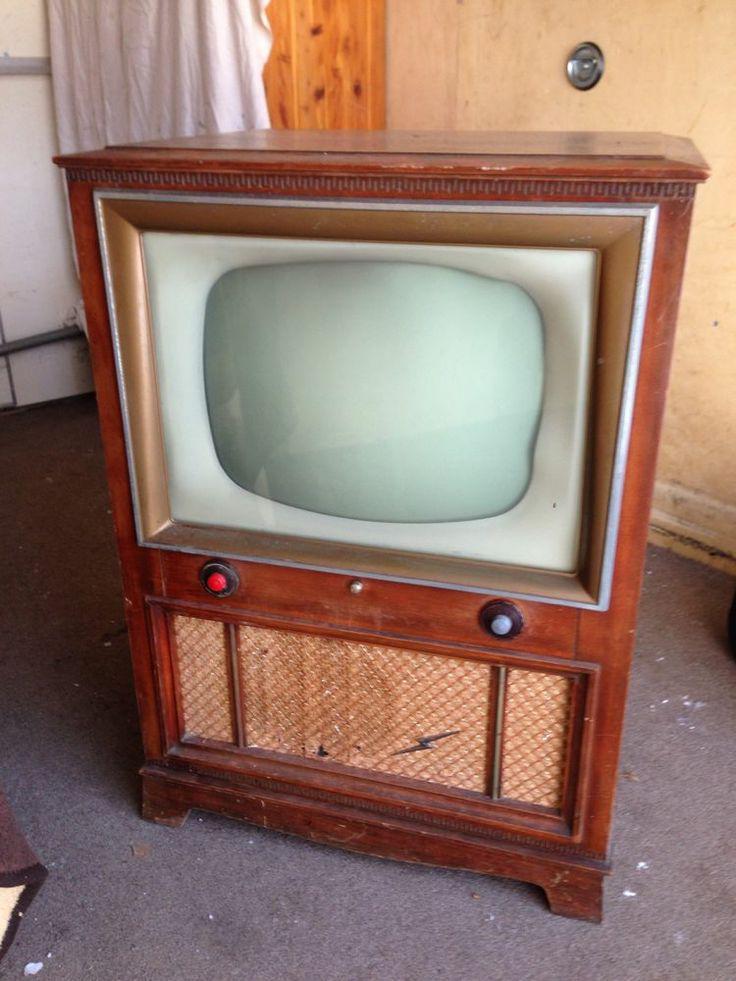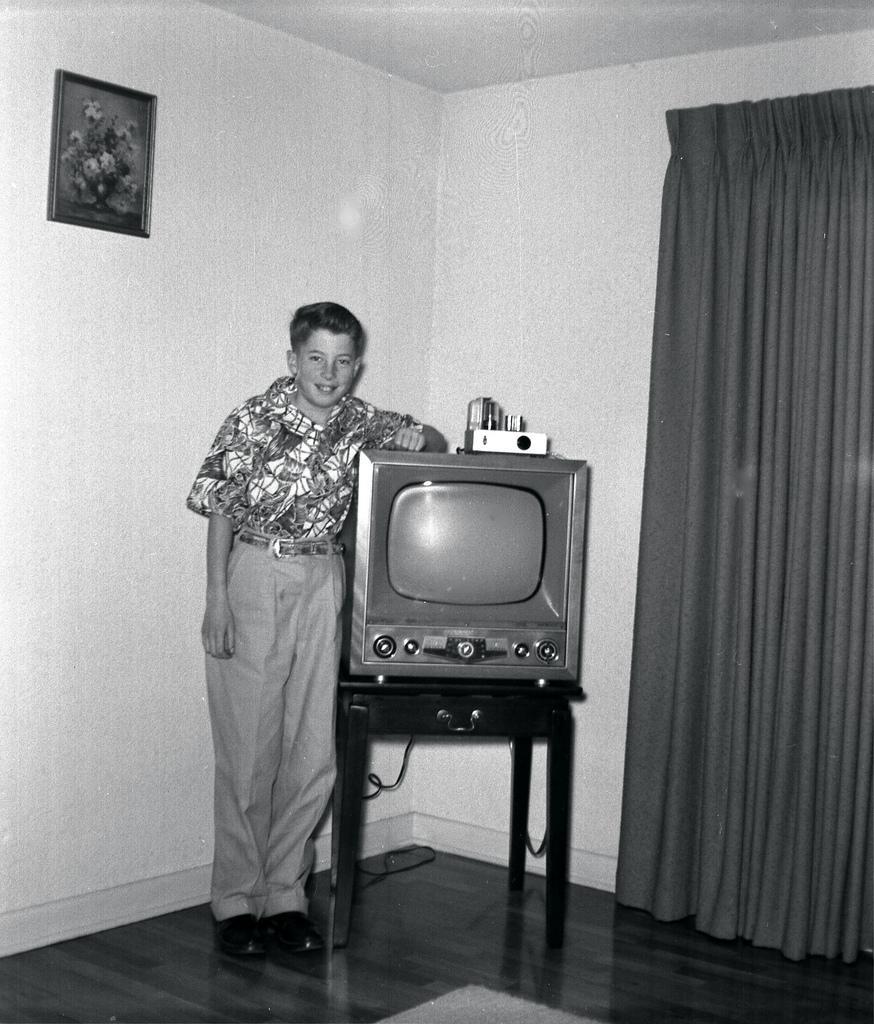The first image is the image on the left, the second image is the image on the right. Analyze the images presented: Is the assertion "There is one person next to a television" valid? Answer yes or no. Yes. The first image is the image on the left, the second image is the image on the right. Analyze the images presented: Is the assertion "In one of the images, there is a single person by the TV." valid? Answer yes or no. Yes. 